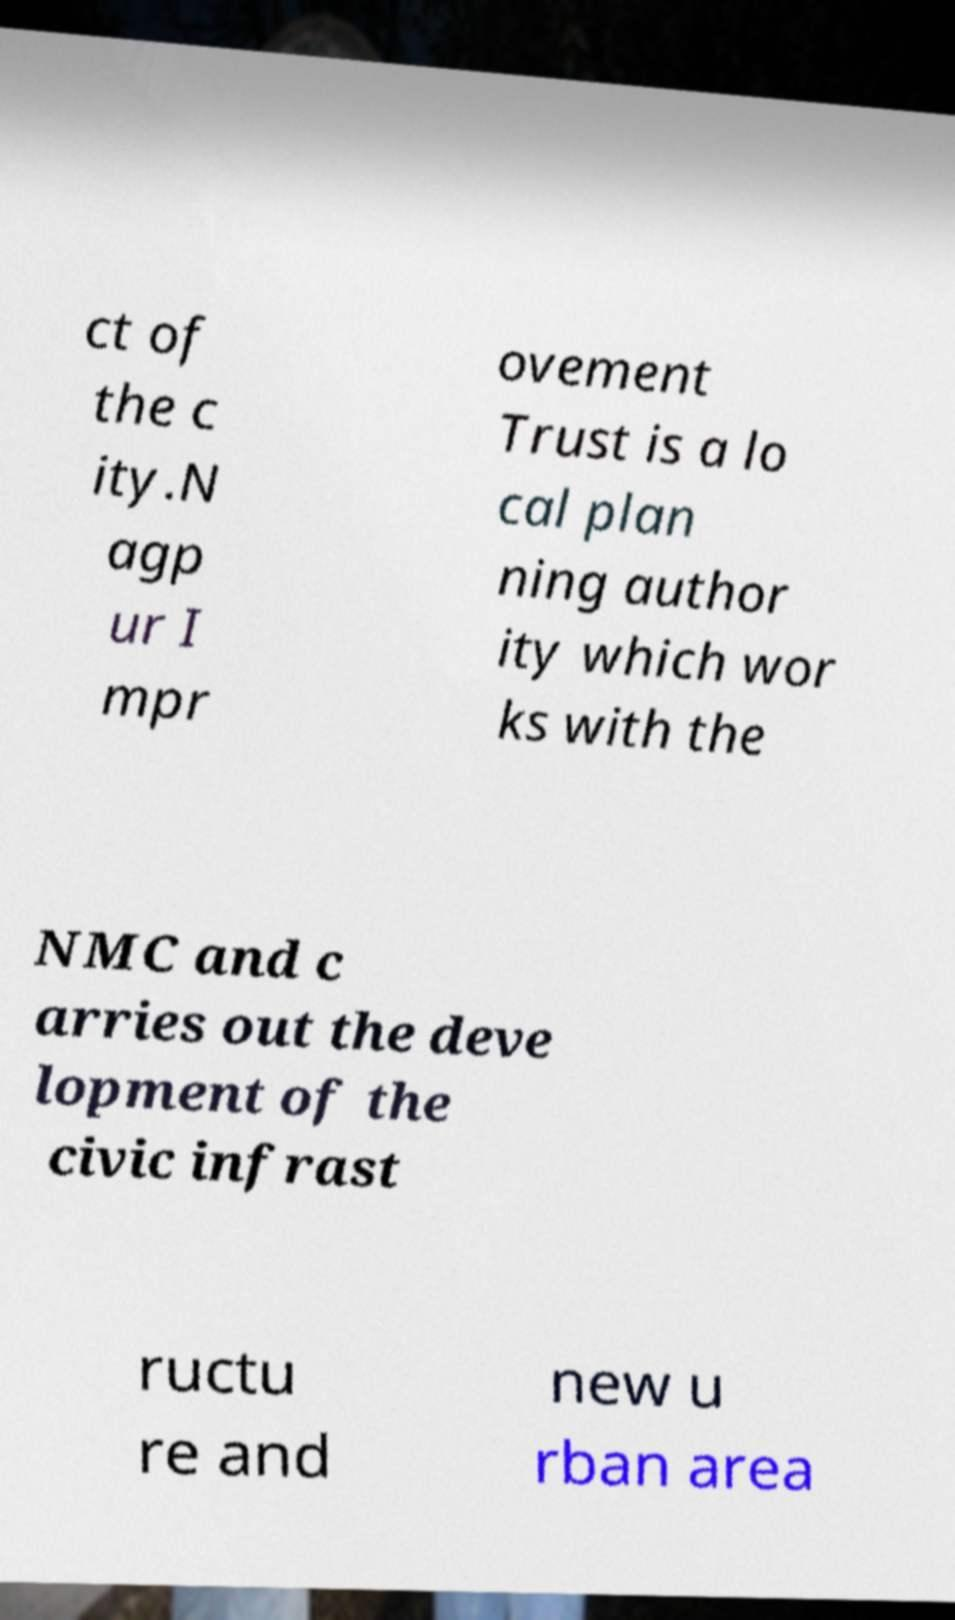Can you read and provide the text displayed in the image?This photo seems to have some interesting text. Can you extract and type it out for me? ct of the c ity.N agp ur I mpr ovement Trust is a lo cal plan ning author ity which wor ks with the NMC and c arries out the deve lopment of the civic infrast ructu re and new u rban area 